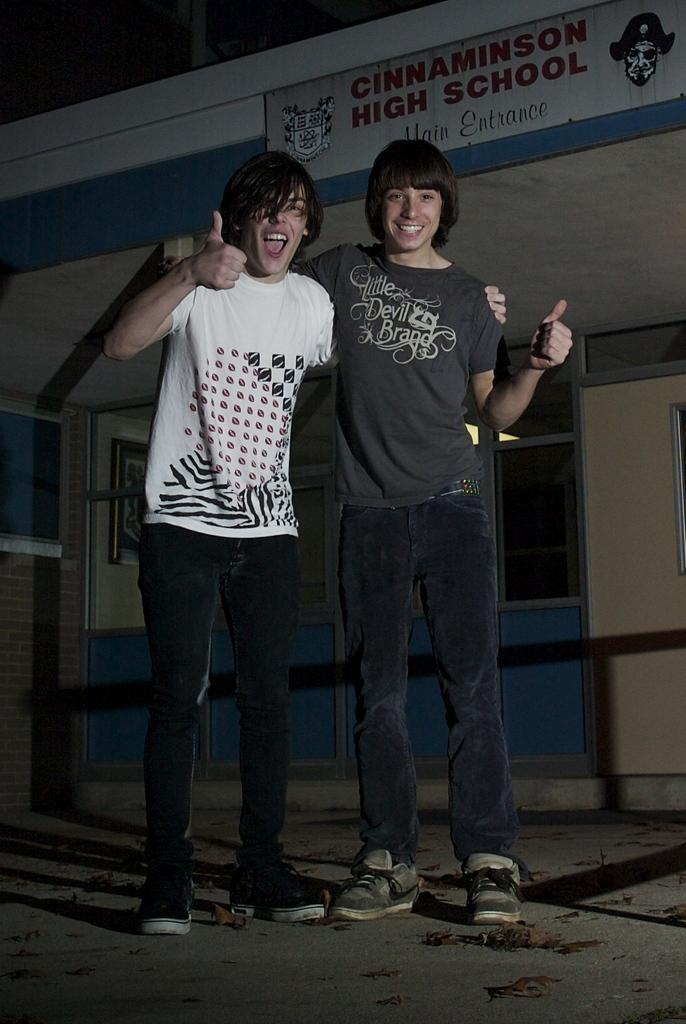How many people are in the image? There are two persons standing in the image. What is the surface on which the persons are standing? The persons are standing on the ground. What can be seen in the background of the image? There is a building in the background of the image. What is written or displayed on the building? There is text visible on the building. What type of thrill treatment is the doctor administering to the persons in the image? There is no doctor or thrill treatment present in the image. 